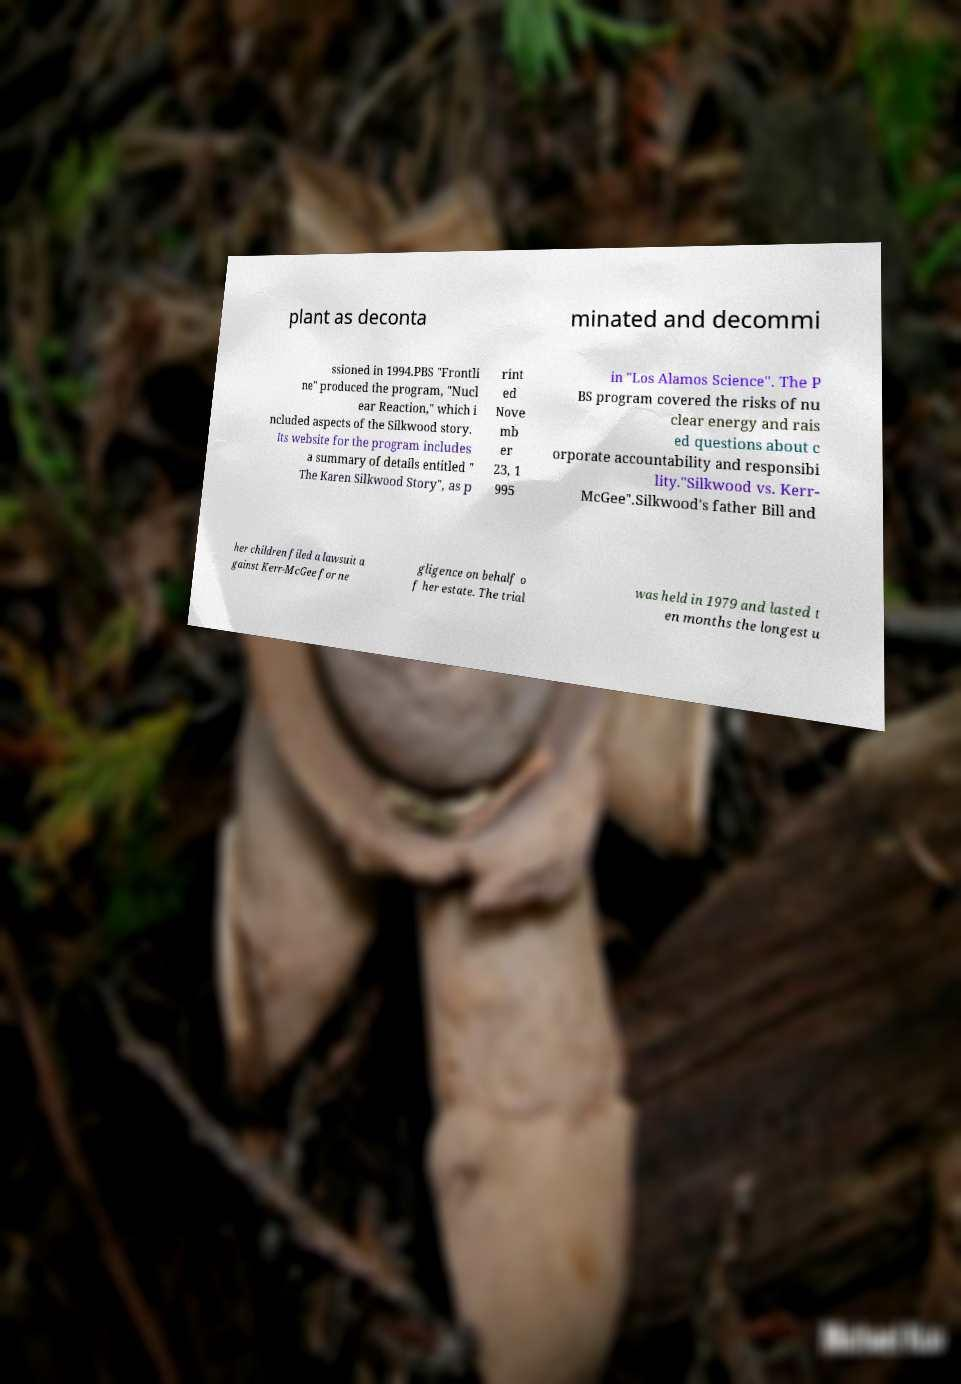Can you accurately transcribe the text from the provided image for me? plant as deconta minated and decommi ssioned in 1994.PBS "Frontli ne" produced the program, "Nucl ear Reaction," which i ncluded aspects of the Silkwood story. Its website for the program includes a summary of details entitled " The Karen Silkwood Story", as p rint ed Nove mb er 23, 1 995 in "Los Alamos Science". The P BS program covered the risks of nu clear energy and rais ed questions about c orporate accountability and responsibi lity."Silkwood vs. Kerr- McGee".Silkwood's father Bill and her children filed a lawsuit a gainst Kerr-McGee for ne gligence on behalf o f her estate. The trial was held in 1979 and lasted t en months the longest u 